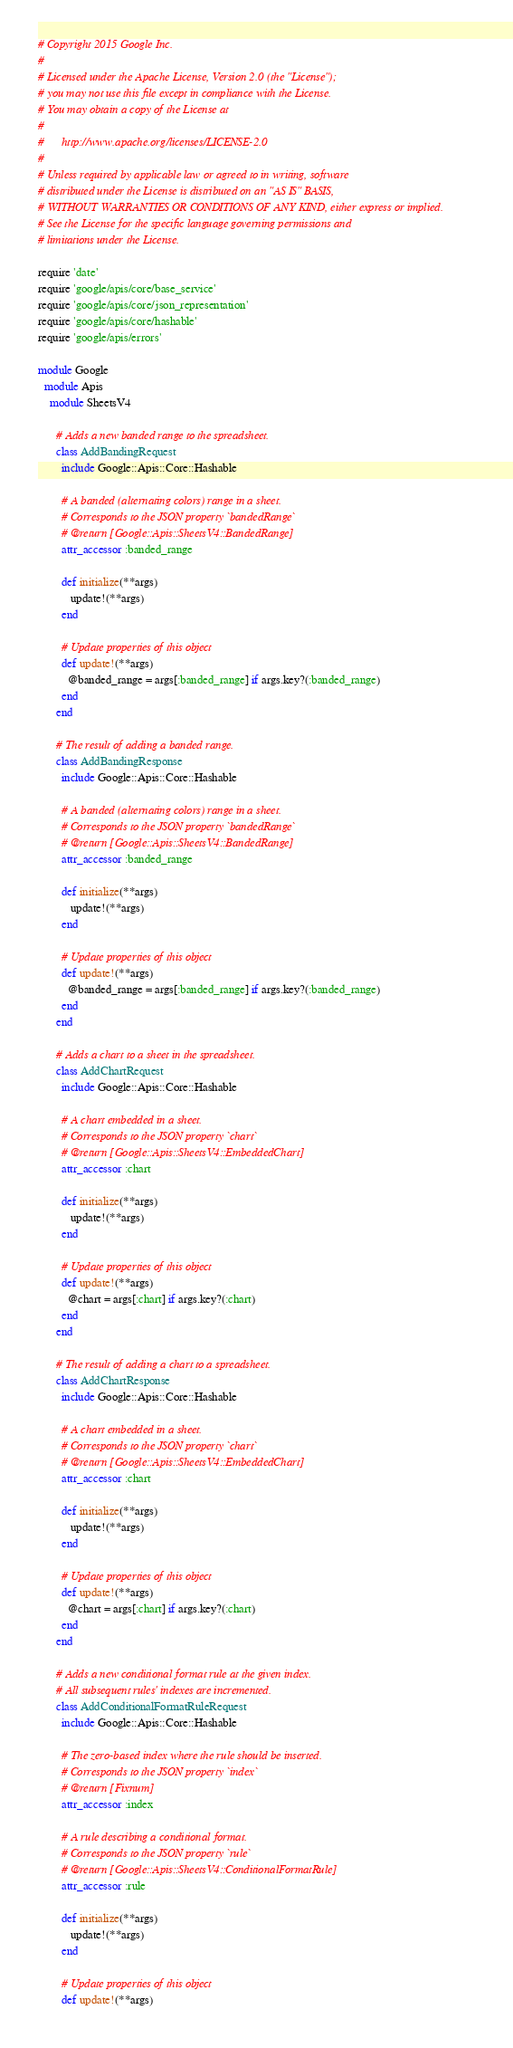<code> <loc_0><loc_0><loc_500><loc_500><_Ruby_># Copyright 2015 Google Inc.
#
# Licensed under the Apache License, Version 2.0 (the "License");
# you may not use this file except in compliance with the License.
# You may obtain a copy of the License at
#
#      http://www.apache.org/licenses/LICENSE-2.0
#
# Unless required by applicable law or agreed to in writing, software
# distributed under the License is distributed on an "AS IS" BASIS,
# WITHOUT WARRANTIES OR CONDITIONS OF ANY KIND, either express or implied.
# See the License for the specific language governing permissions and
# limitations under the License.

require 'date'
require 'google/apis/core/base_service'
require 'google/apis/core/json_representation'
require 'google/apis/core/hashable'
require 'google/apis/errors'

module Google
  module Apis
    module SheetsV4
      
      # Adds a new banded range to the spreadsheet.
      class AddBandingRequest
        include Google::Apis::Core::Hashable
      
        # A banded (alternating colors) range in a sheet.
        # Corresponds to the JSON property `bandedRange`
        # @return [Google::Apis::SheetsV4::BandedRange]
        attr_accessor :banded_range
      
        def initialize(**args)
           update!(**args)
        end
      
        # Update properties of this object
        def update!(**args)
          @banded_range = args[:banded_range] if args.key?(:banded_range)
        end
      end
      
      # The result of adding a banded range.
      class AddBandingResponse
        include Google::Apis::Core::Hashable
      
        # A banded (alternating colors) range in a sheet.
        # Corresponds to the JSON property `bandedRange`
        # @return [Google::Apis::SheetsV4::BandedRange]
        attr_accessor :banded_range
      
        def initialize(**args)
           update!(**args)
        end
      
        # Update properties of this object
        def update!(**args)
          @banded_range = args[:banded_range] if args.key?(:banded_range)
        end
      end
      
      # Adds a chart to a sheet in the spreadsheet.
      class AddChartRequest
        include Google::Apis::Core::Hashable
      
        # A chart embedded in a sheet.
        # Corresponds to the JSON property `chart`
        # @return [Google::Apis::SheetsV4::EmbeddedChart]
        attr_accessor :chart
      
        def initialize(**args)
           update!(**args)
        end
      
        # Update properties of this object
        def update!(**args)
          @chart = args[:chart] if args.key?(:chart)
        end
      end
      
      # The result of adding a chart to a spreadsheet.
      class AddChartResponse
        include Google::Apis::Core::Hashable
      
        # A chart embedded in a sheet.
        # Corresponds to the JSON property `chart`
        # @return [Google::Apis::SheetsV4::EmbeddedChart]
        attr_accessor :chart
      
        def initialize(**args)
           update!(**args)
        end
      
        # Update properties of this object
        def update!(**args)
          @chart = args[:chart] if args.key?(:chart)
        end
      end
      
      # Adds a new conditional format rule at the given index.
      # All subsequent rules' indexes are incremented.
      class AddConditionalFormatRuleRequest
        include Google::Apis::Core::Hashable
      
        # The zero-based index where the rule should be inserted.
        # Corresponds to the JSON property `index`
        # @return [Fixnum]
        attr_accessor :index
      
        # A rule describing a conditional format.
        # Corresponds to the JSON property `rule`
        # @return [Google::Apis::SheetsV4::ConditionalFormatRule]
        attr_accessor :rule
      
        def initialize(**args)
           update!(**args)
        end
      
        # Update properties of this object
        def update!(**args)</code> 